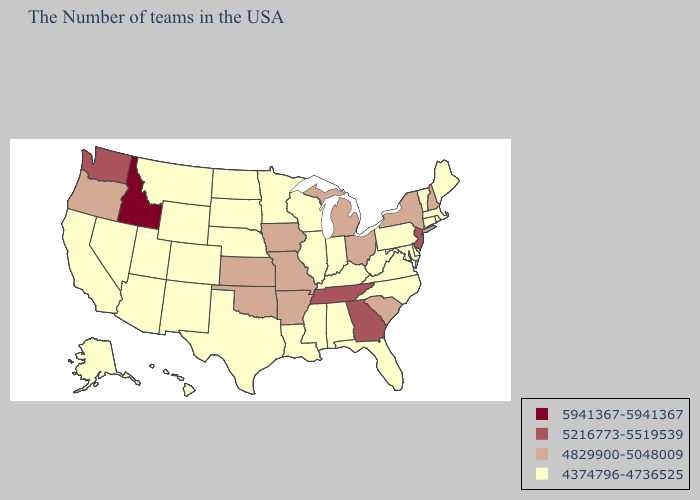Among the states that border South Carolina , does Georgia have the lowest value?
Be succinct. No. What is the value of Maine?
Write a very short answer. 4374796-4736525. Does Virginia have the highest value in the USA?
Quick response, please. No. Name the states that have a value in the range 4374796-4736525?
Write a very short answer. Maine, Massachusetts, Rhode Island, Vermont, Connecticut, Delaware, Maryland, Pennsylvania, Virginia, North Carolina, West Virginia, Florida, Kentucky, Indiana, Alabama, Wisconsin, Illinois, Mississippi, Louisiana, Minnesota, Nebraska, Texas, South Dakota, North Dakota, Wyoming, Colorado, New Mexico, Utah, Montana, Arizona, Nevada, California, Alaska, Hawaii. Name the states that have a value in the range 5941367-5941367?
Concise answer only. Idaho. Name the states that have a value in the range 5941367-5941367?
Keep it brief. Idaho. What is the value of South Carolina?
Answer briefly. 4829900-5048009. What is the value of Maine?
Quick response, please. 4374796-4736525. Does Missouri have the highest value in the MidWest?
Quick response, please. Yes. What is the highest value in the USA?
Short answer required. 5941367-5941367. Name the states that have a value in the range 4374796-4736525?
Give a very brief answer. Maine, Massachusetts, Rhode Island, Vermont, Connecticut, Delaware, Maryland, Pennsylvania, Virginia, North Carolina, West Virginia, Florida, Kentucky, Indiana, Alabama, Wisconsin, Illinois, Mississippi, Louisiana, Minnesota, Nebraska, Texas, South Dakota, North Dakota, Wyoming, Colorado, New Mexico, Utah, Montana, Arizona, Nevada, California, Alaska, Hawaii. Name the states that have a value in the range 5941367-5941367?
Short answer required. Idaho. Name the states that have a value in the range 5941367-5941367?
Concise answer only. Idaho. What is the highest value in states that border Kansas?
Concise answer only. 4829900-5048009. Name the states that have a value in the range 4829900-5048009?
Short answer required. New Hampshire, New York, South Carolina, Ohio, Michigan, Missouri, Arkansas, Iowa, Kansas, Oklahoma, Oregon. 